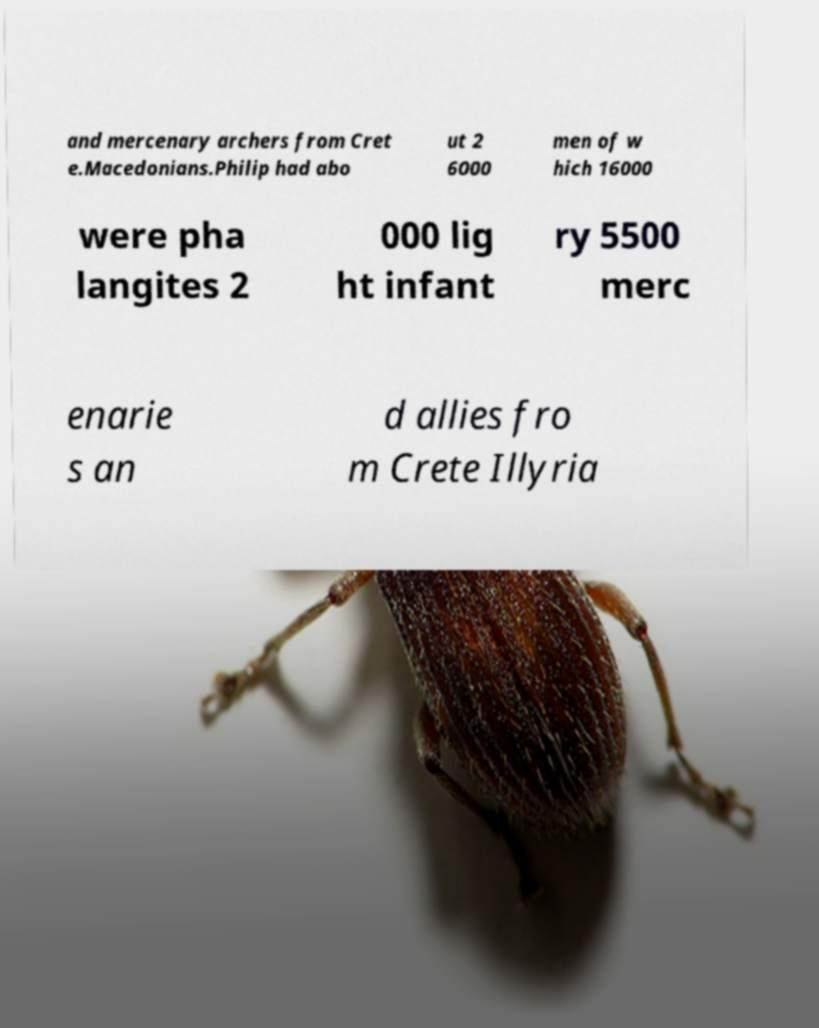There's text embedded in this image that I need extracted. Can you transcribe it verbatim? and mercenary archers from Cret e.Macedonians.Philip had abo ut 2 6000 men of w hich 16000 were pha langites 2 000 lig ht infant ry 5500 merc enarie s an d allies fro m Crete Illyria 